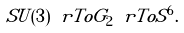Convert formula to latex. <formula><loc_0><loc_0><loc_500><loc_500>S U ( 3 ) \ r T o G _ { 2 } \ r T o S ^ { 6 } .</formula> 